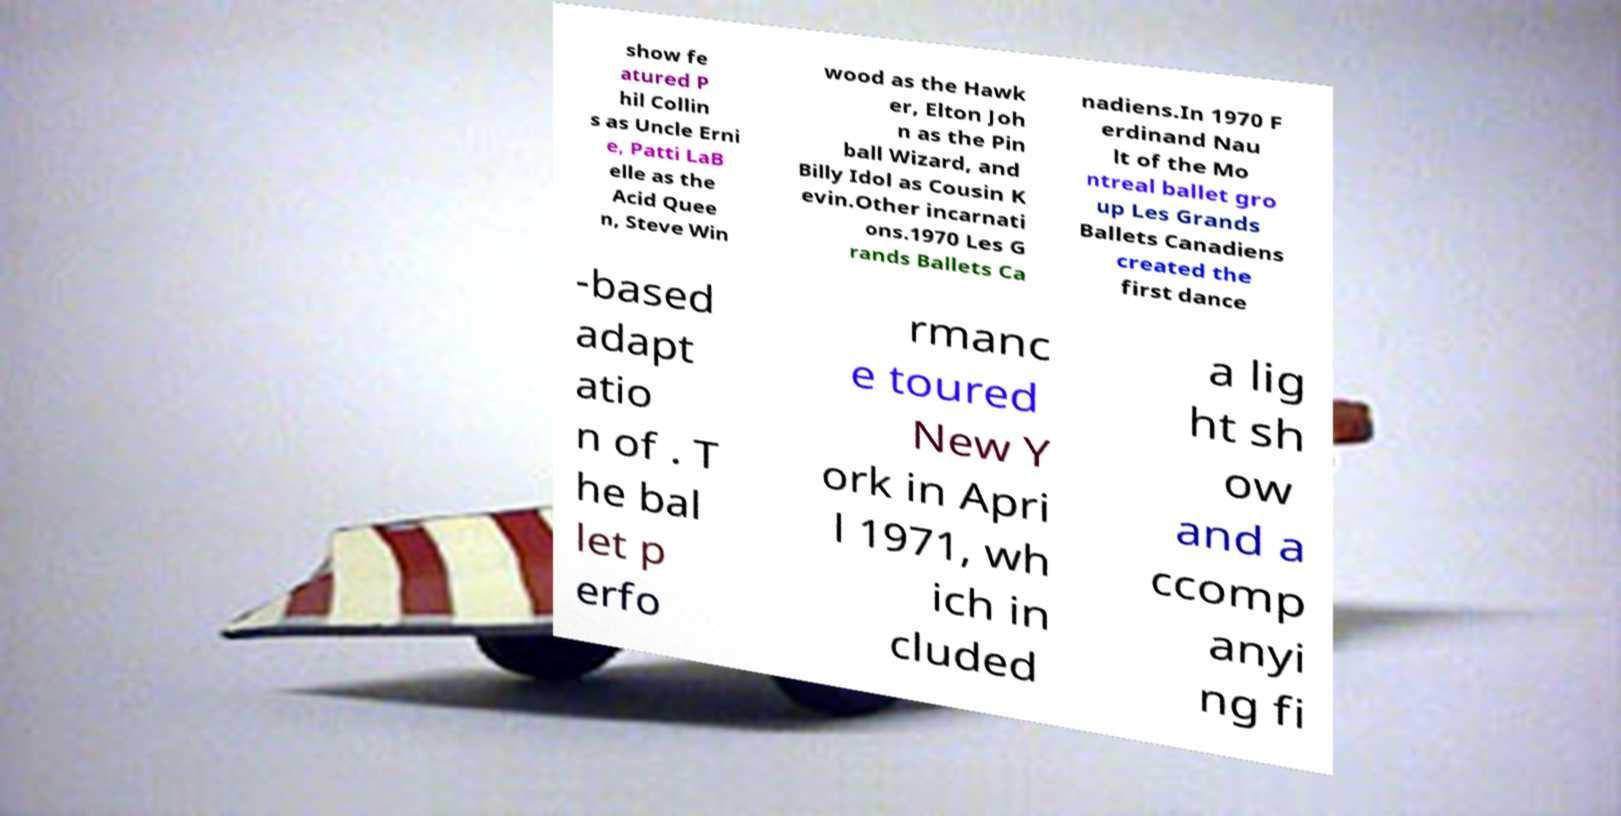What messages or text are displayed in this image? I need them in a readable, typed format. show fe atured P hil Collin s as Uncle Erni e, Patti LaB elle as the Acid Quee n, Steve Win wood as the Hawk er, Elton Joh n as the Pin ball Wizard, and Billy Idol as Cousin K evin.Other incarnati ons.1970 Les G rands Ballets Ca nadiens.In 1970 F erdinand Nau lt of the Mo ntreal ballet gro up Les Grands Ballets Canadiens created the first dance -based adapt atio n of . T he bal let p erfo rmanc e toured New Y ork in Apri l 1971, wh ich in cluded a lig ht sh ow and a ccomp anyi ng fi 